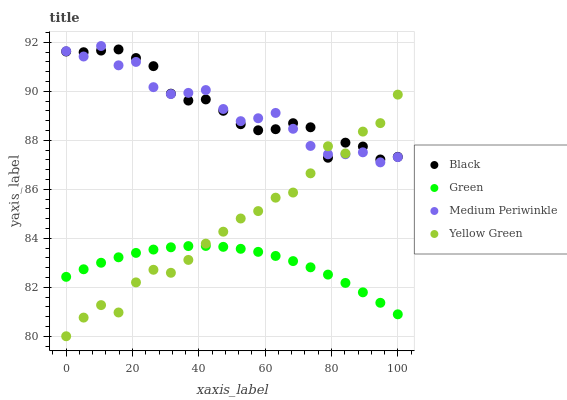Does Green have the minimum area under the curve?
Answer yes or no. Yes. Does Black have the maximum area under the curve?
Answer yes or no. Yes. Does Yellow Green have the minimum area under the curve?
Answer yes or no. No. Does Yellow Green have the maximum area under the curve?
Answer yes or no. No. Is Green the smoothest?
Answer yes or no. Yes. Is Yellow Green the roughest?
Answer yes or no. Yes. Is Black the smoothest?
Answer yes or no. No. Is Black the roughest?
Answer yes or no. No. Does Yellow Green have the lowest value?
Answer yes or no. Yes. Does Black have the lowest value?
Answer yes or no. No. Does Medium Periwinkle have the highest value?
Answer yes or no. Yes. Does Black have the highest value?
Answer yes or no. No. Is Green less than Medium Periwinkle?
Answer yes or no. Yes. Is Black greater than Green?
Answer yes or no. Yes. Does Black intersect Yellow Green?
Answer yes or no. Yes. Is Black less than Yellow Green?
Answer yes or no. No. Is Black greater than Yellow Green?
Answer yes or no. No. Does Green intersect Medium Periwinkle?
Answer yes or no. No. 